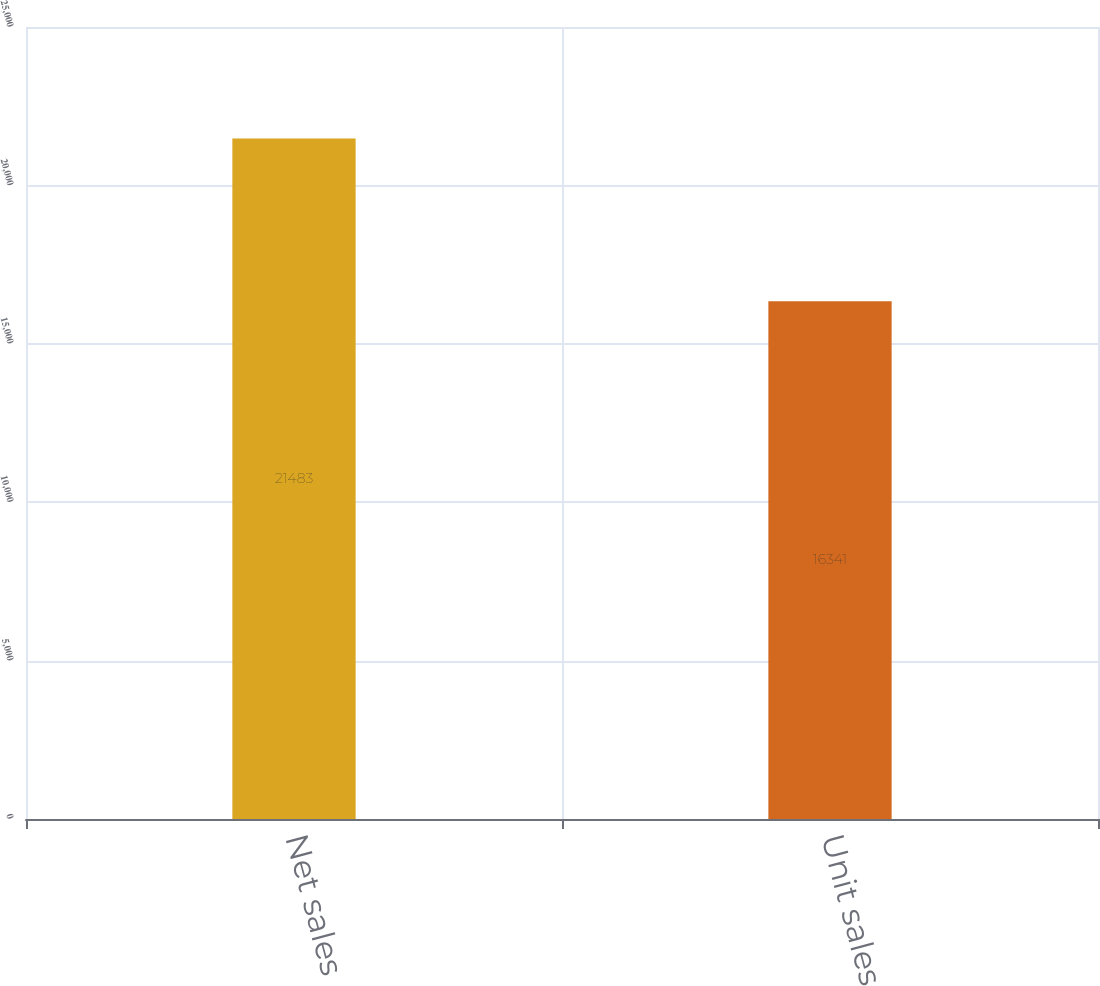Convert chart. <chart><loc_0><loc_0><loc_500><loc_500><bar_chart><fcel>Net sales<fcel>Unit sales<nl><fcel>21483<fcel>16341<nl></chart> 